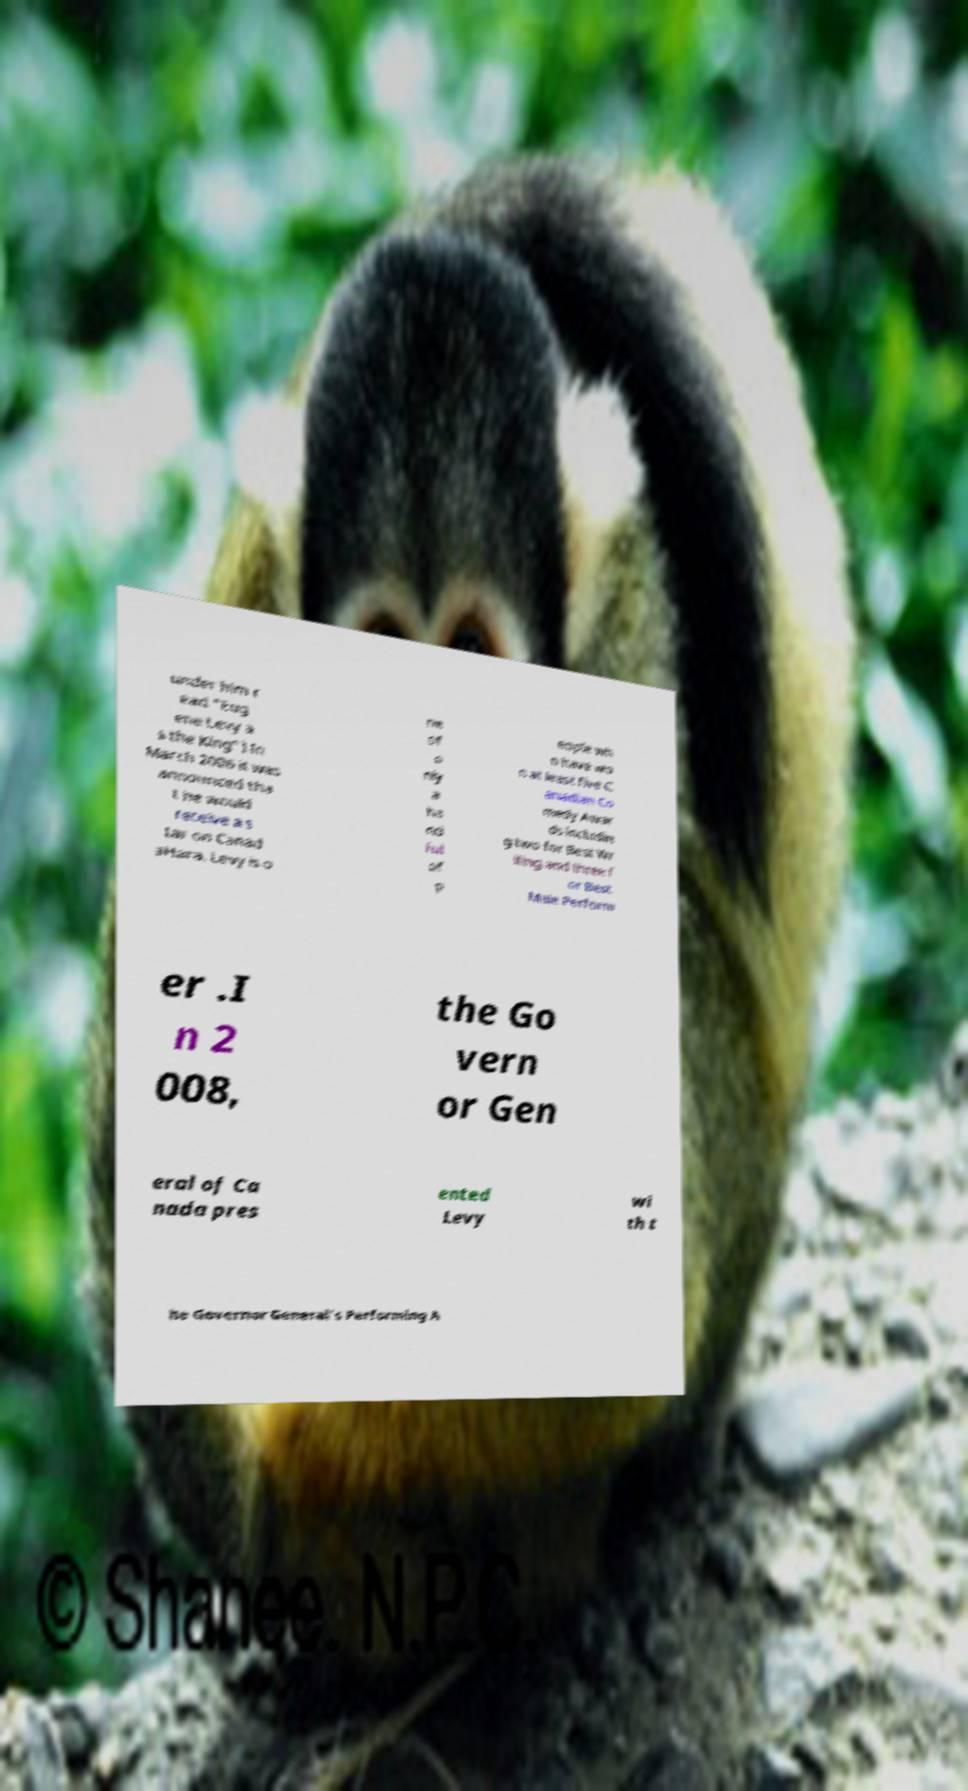Please identify and transcribe the text found in this image. under him r ead "Eug ene Levy a s the King").In March 2006 it was announced tha t he would receive a s tar on Canad aHara. Levy is o ne of o nly a ha nd ful of p eople wh o have wo n at least five C anadian Co medy Awar ds includin g two for Best Wr iting and three f or Best Male Perform er .I n 2 008, the Go vern or Gen eral of Ca nada pres ented Levy wi th t he Governor General's Performing A 